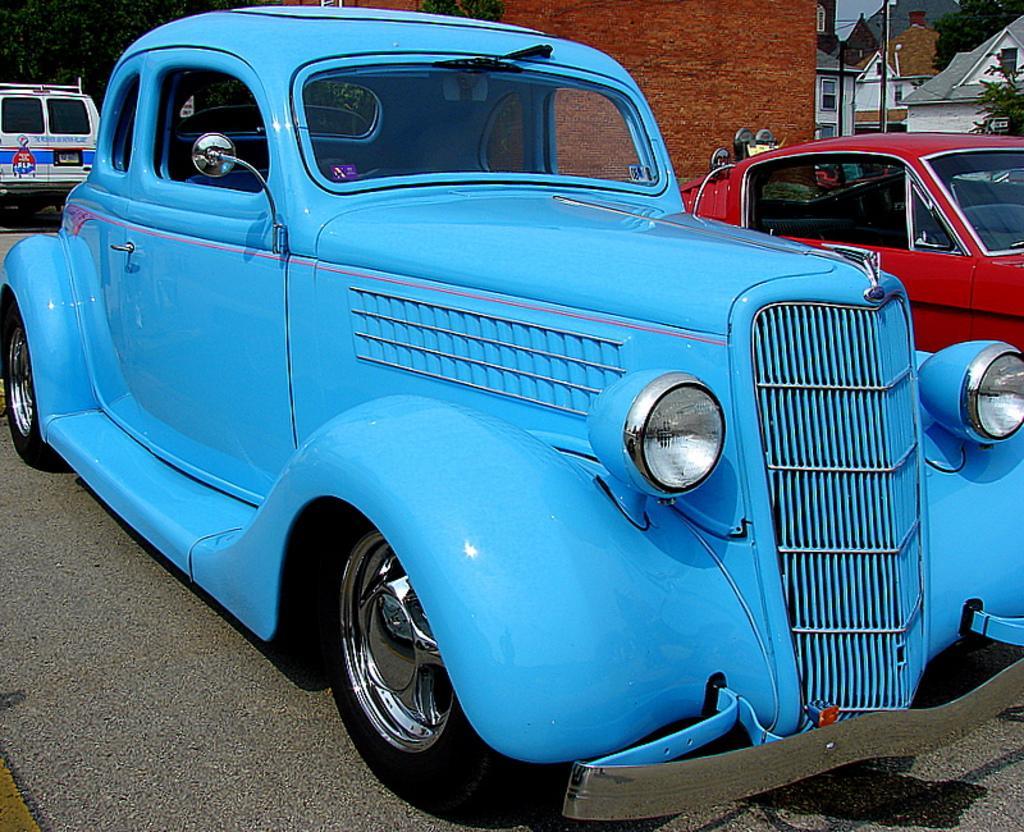Can you describe this image briefly? In this picture, there is a car in the center which is in blue in color. Beside it, there is another car which is in red in color. At the top left, there is a truck and trees. In the background, there are buildings with bricks, roof tiles, windows etc 